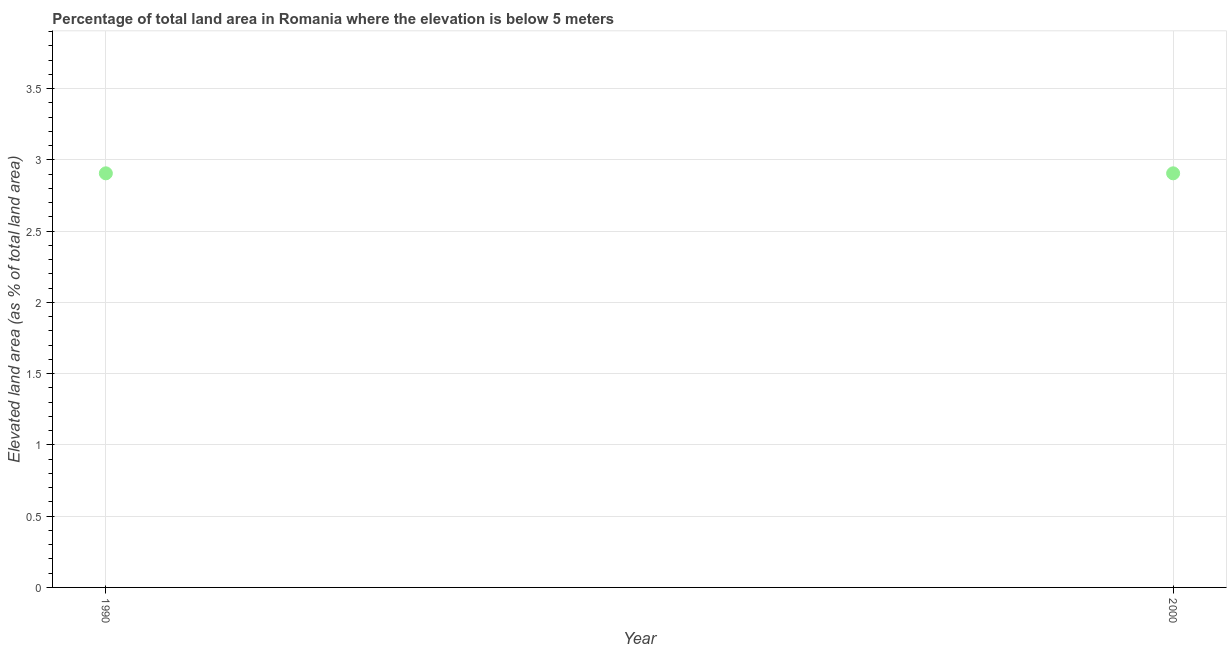What is the total elevated land area in 1990?
Your response must be concise. 2.91. Across all years, what is the maximum total elevated land area?
Provide a succinct answer. 2.91. Across all years, what is the minimum total elevated land area?
Give a very brief answer. 2.91. In which year was the total elevated land area maximum?
Your answer should be very brief. 1990. What is the sum of the total elevated land area?
Offer a very short reply. 5.81. What is the difference between the total elevated land area in 1990 and 2000?
Provide a short and direct response. 0. What is the average total elevated land area per year?
Your response must be concise. 2.91. What is the median total elevated land area?
Provide a succinct answer. 2.91. In how many years, is the total elevated land area greater than 0.1 %?
Offer a very short reply. 2. What is the ratio of the total elevated land area in 1990 to that in 2000?
Offer a terse response. 1. Does the total elevated land area monotonically increase over the years?
Your response must be concise. No. How many years are there in the graph?
Provide a short and direct response. 2. What is the difference between two consecutive major ticks on the Y-axis?
Offer a terse response. 0.5. Does the graph contain any zero values?
Your answer should be very brief. No. What is the title of the graph?
Ensure brevity in your answer.  Percentage of total land area in Romania where the elevation is below 5 meters. What is the label or title of the Y-axis?
Your answer should be very brief. Elevated land area (as % of total land area). What is the Elevated land area (as % of total land area) in 1990?
Your response must be concise. 2.91. What is the Elevated land area (as % of total land area) in 2000?
Give a very brief answer. 2.91. What is the ratio of the Elevated land area (as % of total land area) in 1990 to that in 2000?
Ensure brevity in your answer.  1. 